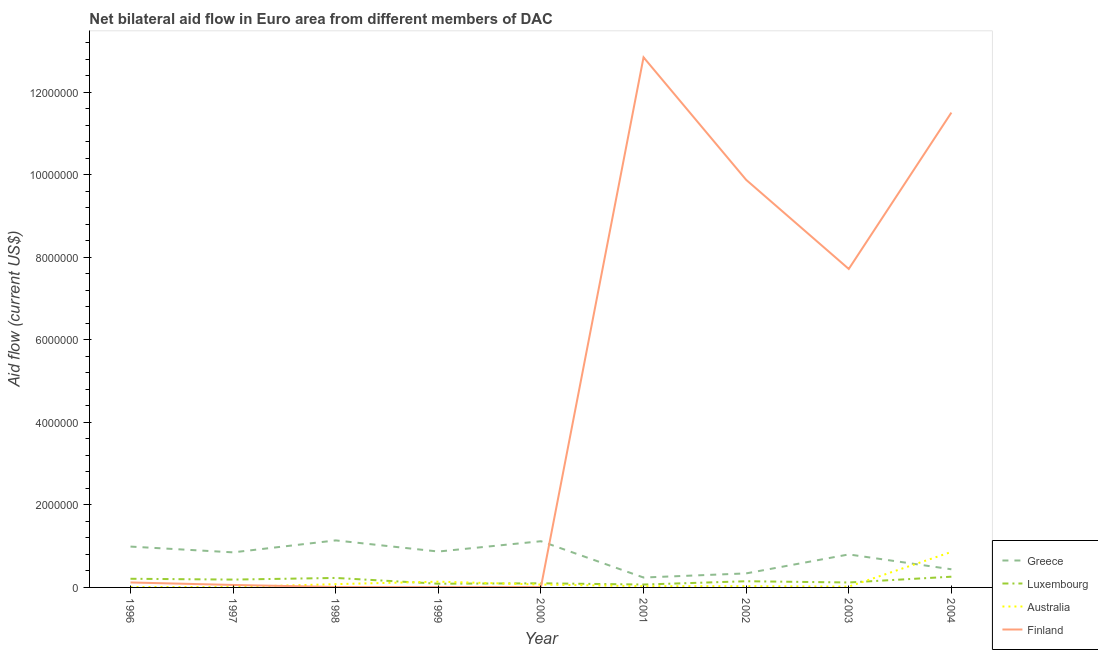Is the number of lines equal to the number of legend labels?
Your response must be concise. Yes. What is the amount of aid given by greece in 1997?
Give a very brief answer. 8.50e+05. Across all years, what is the maximum amount of aid given by finland?
Give a very brief answer. 1.28e+07. Across all years, what is the minimum amount of aid given by australia?
Your answer should be very brief. 10000. In which year was the amount of aid given by greece maximum?
Provide a succinct answer. 1998. In which year was the amount of aid given by australia minimum?
Provide a succinct answer. 1996. What is the total amount of aid given by luxembourg in the graph?
Offer a terse response. 1.42e+06. What is the difference between the amount of aid given by finland in 1996 and that in 1997?
Offer a terse response. 6.00e+04. What is the difference between the amount of aid given by australia in 1997 and the amount of aid given by finland in 2004?
Offer a very short reply. -1.15e+07. What is the average amount of aid given by finland per year?
Keep it short and to the point. 4.69e+06. In the year 1998, what is the difference between the amount of aid given by luxembourg and amount of aid given by australia?
Provide a succinct answer. 1.50e+05. In how many years, is the amount of aid given by australia greater than 1200000 US$?
Your answer should be very brief. 0. Is the amount of aid given by australia in 1997 less than that in 2000?
Offer a very short reply. Yes. Is the difference between the amount of aid given by luxembourg in 1999 and 2002 greater than the difference between the amount of aid given by finland in 1999 and 2002?
Ensure brevity in your answer.  Yes. What is the difference between the highest and the second highest amount of aid given by finland?
Ensure brevity in your answer.  1.34e+06. What is the difference between the highest and the lowest amount of aid given by australia?
Provide a short and direct response. 8.50e+05. In how many years, is the amount of aid given by australia greater than the average amount of aid given by australia taken over all years?
Offer a very short reply. 2. Is the sum of the amount of aid given by luxembourg in 2002 and 2003 greater than the maximum amount of aid given by finland across all years?
Offer a very short reply. No. Does the amount of aid given by greece monotonically increase over the years?
Provide a short and direct response. No. Is the amount of aid given by australia strictly greater than the amount of aid given by luxembourg over the years?
Provide a short and direct response. No. How many lines are there?
Offer a terse response. 4. What is the difference between two consecutive major ticks on the Y-axis?
Your response must be concise. 2.00e+06. How are the legend labels stacked?
Your response must be concise. Vertical. What is the title of the graph?
Ensure brevity in your answer.  Net bilateral aid flow in Euro area from different members of DAC. Does "Permission" appear as one of the legend labels in the graph?
Give a very brief answer. No. What is the label or title of the X-axis?
Keep it short and to the point. Year. What is the Aid flow (current US$) of Greece in 1996?
Your answer should be very brief. 9.90e+05. What is the Aid flow (current US$) in Luxembourg in 1996?
Make the answer very short. 2.10e+05. What is the Aid flow (current US$) in Australia in 1996?
Your response must be concise. 10000. What is the Aid flow (current US$) of Finland in 1996?
Provide a short and direct response. 1.20e+05. What is the Aid flow (current US$) in Greece in 1997?
Provide a succinct answer. 8.50e+05. What is the Aid flow (current US$) of Luxembourg in 1997?
Provide a succinct answer. 1.90e+05. What is the Aid flow (current US$) of Finland in 1997?
Make the answer very short. 6.00e+04. What is the Aid flow (current US$) in Greece in 1998?
Give a very brief answer. 1.14e+06. What is the Aid flow (current US$) of Greece in 1999?
Your answer should be very brief. 8.70e+05. What is the Aid flow (current US$) of Australia in 1999?
Provide a succinct answer. 1.40e+05. What is the Aid flow (current US$) of Finland in 1999?
Give a very brief answer. 10000. What is the Aid flow (current US$) in Greece in 2000?
Offer a very short reply. 1.12e+06. What is the Aid flow (current US$) of Luxembourg in 2000?
Offer a very short reply. 1.00e+05. What is the Aid flow (current US$) of Greece in 2001?
Offer a terse response. 2.40e+05. What is the Aid flow (current US$) in Finland in 2001?
Your answer should be compact. 1.28e+07. What is the Aid flow (current US$) of Australia in 2002?
Provide a short and direct response. 3.00e+04. What is the Aid flow (current US$) of Finland in 2002?
Offer a very short reply. 9.88e+06. What is the Aid flow (current US$) in Luxembourg in 2003?
Your answer should be very brief. 1.20e+05. What is the Aid flow (current US$) of Finland in 2003?
Your answer should be compact. 7.72e+06. What is the Aid flow (current US$) of Australia in 2004?
Offer a very short reply. 8.60e+05. What is the Aid flow (current US$) of Finland in 2004?
Your answer should be very brief. 1.15e+07. Across all years, what is the maximum Aid flow (current US$) of Greece?
Ensure brevity in your answer.  1.14e+06. Across all years, what is the maximum Aid flow (current US$) of Australia?
Your answer should be very brief. 8.60e+05. Across all years, what is the maximum Aid flow (current US$) in Finland?
Make the answer very short. 1.28e+07. Across all years, what is the minimum Aid flow (current US$) of Greece?
Give a very brief answer. 2.40e+05. Across all years, what is the minimum Aid flow (current US$) in Luxembourg?
Offer a terse response. 7.00e+04. Across all years, what is the minimum Aid flow (current US$) in Australia?
Your response must be concise. 10000. Across all years, what is the minimum Aid flow (current US$) of Finland?
Give a very brief answer. 10000. What is the total Aid flow (current US$) in Greece in the graph?
Ensure brevity in your answer.  6.79e+06. What is the total Aid flow (current US$) in Luxembourg in the graph?
Your answer should be compact. 1.42e+06. What is the total Aid flow (current US$) in Australia in the graph?
Provide a succinct answer. 1.25e+06. What is the total Aid flow (current US$) in Finland in the graph?
Your response must be concise. 4.22e+07. What is the difference between the Aid flow (current US$) of Greece in 1996 and that in 1997?
Make the answer very short. 1.40e+05. What is the difference between the Aid flow (current US$) of Australia in 1996 and that in 1997?
Your response must be concise. 0. What is the difference between the Aid flow (current US$) in Luxembourg in 1996 and that in 1998?
Make the answer very short. -2.00e+04. What is the difference between the Aid flow (current US$) of Australia in 1996 and that in 1998?
Provide a succinct answer. -7.00e+04. What is the difference between the Aid flow (current US$) of Luxembourg in 1996 and that in 1999?
Make the answer very short. 1.20e+05. What is the difference between the Aid flow (current US$) in Greece in 1996 and that in 2000?
Offer a very short reply. -1.30e+05. What is the difference between the Aid flow (current US$) in Luxembourg in 1996 and that in 2000?
Give a very brief answer. 1.10e+05. What is the difference between the Aid flow (current US$) of Greece in 1996 and that in 2001?
Give a very brief answer. 7.50e+05. What is the difference between the Aid flow (current US$) of Finland in 1996 and that in 2001?
Your answer should be very brief. -1.27e+07. What is the difference between the Aid flow (current US$) of Greece in 1996 and that in 2002?
Offer a terse response. 6.50e+05. What is the difference between the Aid flow (current US$) of Australia in 1996 and that in 2002?
Your answer should be very brief. -2.00e+04. What is the difference between the Aid flow (current US$) of Finland in 1996 and that in 2002?
Provide a short and direct response. -9.76e+06. What is the difference between the Aid flow (current US$) of Australia in 1996 and that in 2003?
Provide a succinct answer. -10000. What is the difference between the Aid flow (current US$) of Finland in 1996 and that in 2003?
Your answer should be very brief. -7.60e+06. What is the difference between the Aid flow (current US$) in Greece in 1996 and that in 2004?
Your response must be concise. 5.50e+05. What is the difference between the Aid flow (current US$) in Australia in 1996 and that in 2004?
Your answer should be compact. -8.50e+05. What is the difference between the Aid flow (current US$) in Finland in 1996 and that in 2004?
Give a very brief answer. -1.14e+07. What is the difference between the Aid flow (current US$) in Greece in 1997 and that in 1998?
Your answer should be compact. -2.90e+05. What is the difference between the Aid flow (current US$) of Greece in 1997 and that in 1999?
Make the answer very short. -2.00e+04. What is the difference between the Aid flow (current US$) of Luxembourg in 1997 and that in 1999?
Give a very brief answer. 1.00e+05. What is the difference between the Aid flow (current US$) in Australia in 1997 and that in 1999?
Offer a very short reply. -1.30e+05. What is the difference between the Aid flow (current US$) of Finland in 1997 and that in 1999?
Provide a succinct answer. 5.00e+04. What is the difference between the Aid flow (current US$) of Greece in 1997 and that in 2000?
Give a very brief answer. -2.70e+05. What is the difference between the Aid flow (current US$) in Luxembourg in 1997 and that in 2000?
Offer a very short reply. 9.00e+04. What is the difference between the Aid flow (current US$) in Australia in 1997 and that in 2000?
Your response must be concise. -6.00e+04. What is the difference between the Aid flow (current US$) in Greece in 1997 and that in 2001?
Ensure brevity in your answer.  6.10e+05. What is the difference between the Aid flow (current US$) in Luxembourg in 1997 and that in 2001?
Keep it short and to the point. 1.20e+05. What is the difference between the Aid flow (current US$) in Australia in 1997 and that in 2001?
Offer a very short reply. -2.00e+04. What is the difference between the Aid flow (current US$) of Finland in 1997 and that in 2001?
Your answer should be compact. -1.28e+07. What is the difference between the Aid flow (current US$) in Greece in 1997 and that in 2002?
Keep it short and to the point. 5.10e+05. What is the difference between the Aid flow (current US$) in Luxembourg in 1997 and that in 2002?
Your answer should be compact. 4.00e+04. What is the difference between the Aid flow (current US$) of Australia in 1997 and that in 2002?
Provide a short and direct response. -2.00e+04. What is the difference between the Aid flow (current US$) of Finland in 1997 and that in 2002?
Make the answer very short. -9.82e+06. What is the difference between the Aid flow (current US$) of Greece in 1997 and that in 2003?
Provide a succinct answer. 5.00e+04. What is the difference between the Aid flow (current US$) in Australia in 1997 and that in 2003?
Your answer should be compact. -10000. What is the difference between the Aid flow (current US$) in Finland in 1997 and that in 2003?
Keep it short and to the point. -7.66e+06. What is the difference between the Aid flow (current US$) in Luxembourg in 1997 and that in 2004?
Your answer should be very brief. -7.00e+04. What is the difference between the Aid flow (current US$) of Australia in 1997 and that in 2004?
Make the answer very short. -8.50e+05. What is the difference between the Aid flow (current US$) of Finland in 1997 and that in 2004?
Your response must be concise. -1.14e+07. What is the difference between the Aid flow (current US$) in Greece in 1998 and that in 1999?
Ensure brevity in your answer.  2.70e+05. What is the difference between the Aid flow (current US$) in Luxembourg in 1998 and that in 1999?
Keep it short and to the point. 1.40e+05. What is the difference between the Aid flow (current US$) of Australia in 1998 and that in 1999?
Offer a terse response. -6.00e+04. What is the difference between the Aid flow (current US$) of Luxembourg in 1998 and that in 2000?
Ensure brevity in your answer.  1.30e+05. What is the difference between the Aid flow (current US$) of Australia in 1998 and that in 2000?
Your answer should be compact. 10000. What is the difference between the Aid flow (current US$) in Finland in 1998 and that in 2001?
Make the answer very short. -1.28e+07. What is the difference between the Aid flow (current US$) in Greece in 1998 and that in 2002?
Keep it short and to the point. 8.00e+05. What is the difference between the Aid flow (current US$) in Luxembourg in 1998 and that in 2002?
Give a very brief answer. 8.00e+04. What is the difference between the Aid flow (current US$) in Australia in 1998 and that in 2002?
Provide a short and direct response. 5.00e+04. What is the difference between the Aid flow (current US$) of Finland in 1998 and that in 2002?
Your answer should be compact. -9.87e+06. What is the difference between the Aid flow (current US$) of Finland in 1998 and that in 2003?
Provide a short and direct response. -7.71e+06. What is the difference between the Aid flow (current US$) of Greece in 1998 and that in 2004?
Your answer should be compact. 7.00e+05. What is the difference between the Aid flow (current US$) of Australia in 1998 and that in 2004?
Make the answer very short. -7.80e+05. What is the difference between the Aid flow (current US$) of Finland in 1998 and that in 2004?
Your answer should be compact. -1.15e+07. What is the difference between the Aid flow (current US$) in Luxembourg in 1999 and that in 2000?
Give a very brief answer. -10000. What is the difference between the Aid flow (current US$) of Finland in 1999 and that in 2000?
Offer a very short reply. 0. What is the difference between the Aid flow (current US$) in Greece in 1999 and that in 2001?
Provide a short and direct response. 6.30e+05. What is the difference between the Aid flow (current US$) in Luxembourg in 1999 and that in 2001?
Provide a succinct answer. 2.00e+04. What is the difference between the Aid flow (current US$) of Australia in 1999 and that in 2001?
Your answer should be very brief. 1.10e+05. What is the difference between the Aid flow (current US$) in Finland in 1999 and that in 2001?
Your answer should be very brief. -1.28e+07. What is the difference between the Aid flow (current US$) in Greece in 1999 and that in 2002?
Make the answer very short. 5.30e+05. What is the difference between the Aid flow (current US$) in Luxembourg in 1999 and that in 2002?
Your answer should be very brief. -6.00e+04. What is the difference between the Aid flow (current US$) in Australia in 1999 and that in 2002?
Your response must be concise. 1.10e+05. What is the difference between the Aid flow (current US$) of Finland in 1999 and that in 2002?
Your answer should be very brief. -9.87e+06. What is the difference between the Aid flow (current US$) in Greece in 1999 and that in 2003?
Provide a succinct answer. 7.00e+04. What is the difference between the Aid flow (current US$) of Australia in 1999 and that in 2003?
Your response must be concise. 1.20e+05. What is the difference between the Aid flow (current US$) in Finland in 1999 and that in 2003?
Offer a terse response. -7.71e+06. What is the difference between the Aid flow (current US$) in Greece in 1999 and that in 2004?
Your answer should be very brief. 4.30e+05. What is the difference between the Aid flow (current US$) in Luxembourg in 1999 and that in 2004?
Offer a very short reply. -1.70e+05. What is the difference between the Aid flow (current US$) of Australia in 1999 and that in 2004?
Your answer should be compact. -7.20e+05. What is the difference between the Aid flow (current US$) in Finland in 1999 and that in 2004?
Provide a short and direct response. -1.15e+07. What is the difference between the Aid flow (current US$) in Greece in 2000 and that in 2001?
Ensure brevity in your answer.  8.80e+05. What is the difference between the Aid flow (current US$) of Finland in 2000 and that in 2001?
Give a very brief answer. -1.28e+07. What is the difference between the Aid flow (current US$) of Greece in 2000 and that in 2002?
Ensure brevity in your answer.  7.80e+05. What is the difference between the Aid flow (current US$) of Luxembourg in 2000 and that in 2002?
Offer a terse response. -5.00e+04. What is the difference between the Aid flow (current US$) in Australia in 2000 and that in 2002?
Offer a terse response. 4.00e+04. What is the difference between the Aid flow (current US$) of Finland in 2000 and that in 2002?
Make the answer very short. -9.87e+06. What is the difference between the Aid flow (current US$) of Greece in 2000 and that in 2003?
Offer a very short reply. 3.20e+05. What is the difference between the Aid flow (current US$) of Luxembourg in 2000 and that in 2003?
Your answer should be compact. -2.00e+04. What is the difference between the Aid flow (current US$) of Finland in 2000 and that in 2003?
Provide a short and direct response. -7.71e+06. What is the difference between the Aid flow (current US$) in Greece in 2000 and that in 2004?
Keep it short and to the point. 6.80e+05. What is the difference between the Aid flow (current US$) in Luxembourg in 2000 and that in 2004?
Your response must be concise. -1.60e+05. What is the difference between the Aid flow (current US$) in Australia in 2000 and that in 2004?
Your answer should be very brief. -7.90e+05. What is the difference between the Aid flow (current US$) in Finland in 2000 and that in 2004?
Provide a succinct answer. -1.15e+07. What is the difference between the Aid flow (current US$) of Finland in 2001 and that in 2002?
Provide a short and direct response. 2.97e+06. What is the difference between the Aid flow (current US$) in Greece in 2001 and that in 2003?
Make the answer very short. -5.60e+05. What is the difference between the Aid flow (current US$) of Luxembourg in 2001 and that in 2003?
Offer a terse response. -5.00e+04. What is the difference between the Aid flow (current US$) of Australia in 2001 and that in 2003?
Provide a short and direct response. 10000. What is the difference between the Aid flow (current US$) in Finland in 2001 and that in 2003?
Provide a succinct answer. 5.13e+06. What is the difference between the Aid flow (current US$) of Greece in 2001 and that in 2004?
Your response must be concise. -2.00e+05. What is the difference between the Aid flow (current US$) in Australia in 2001 and that in 2004?
Offer a very short reply. -8.30e+05. What is the difference between the Aid flow (current US$) in Finland in 2001 and that in 2004?
Make the answer very short. 1.34e+06. What is the difference between the Aid flow (current US$) of Greece in 2002 and that in 2003?
Your answer should be very brief. -4.60e+05. What is the difference between the Aid flow (current US$) of Luxembourg in 2002 and that in 2003?
Offer a terse response. 3.00e+04. What is the difference between the Aid flow (current US$) in Finland in 2002 and that in 2003?
Offer a terse response. 2.16e+06. What is the difference between the Aid flow (current US$) of Greece in 2002 and that in 2004?
Your answer should be compact. -1.00e+05. What is the difference between the Aid flow (current US$) in Luxembourg in 2002 and that in 2004?
Ensure brevity in your answer.  -1.10e+05. What is the difference between the Aid flow (current US$) in Australia in 2002 and that in 2004?
Ensure brevity in your answer.  -8.30e+05. What is the difference between the Aid flow (current US$) in Finland in 2002 and that in 2004?
Keep it short and to the point. -1.63e+06. What is the difference between the Aid flow (current US$) in Greece in 2003 and that in 2004?
Your answer should be very brief. 3.60e+05. What is the difference between the Aid flow (current US$) of Luxembourg in 2003 and that in 2004?
Ensure brevity in your answer.  -1.40e+05. What is the difference between the Aid flow (current US$) of Australia in 2003 and that in 2004?
Provide a succinct answer. -8.40e+05. What is the difference between the Aid flow (current US$) of Finland in 2003 and that in 2004?
Keep it short and to the point. -3.79e+06. What is the difference between the Aid flow (current US$) in Greece in 1996 and the Aid flow (current US$) in Luxembourg in 1997?
Provide a succinct answer. 8.00e+05. What is the difference between the Aid flow (current US$) in Greece in 1996 and the Aid flow (current US$) in Australia in 1997?
Your answer should be very brief. 9.80e+05. What is the difference between the Aid flow (current US$) of Greece in 1996 and the Aid flow (current US$) of Finland in 1997?
Provide a short and direct response. 9.30e+05. What is the difference between the Aid flow (current US$) of Luxembourg in 1996 and the Aid flow (current US$) of Finland in 1997?
Your response must be concise. 1.50e+05. What is the difference between the Aid flow (current US$) of Australia in 1996 and the Aid flow (current US$) of Finland in 1997?
Give a very brief answer. -5.00e+04. What is the difference between the Aid flow (current US$) of Greece in 1996 and the Aid flow (current US$) of Luxembourg in 1998?
Ensure brevity in your answer.  7.60e+05. What is the difference between the Aid flow (current US$) in Greece in 1996 and the Aid flow (current US$) in Australia in 1998?
Your response must be concise. 9.10e+05. What is the difference between the Aid flow (current US$) of Greece in 1996 and the Aid flow (current US$) of Finland in 1998?
Provide a short and direct response. 9.80e+05. What is the difference between the Aid flow (current US$) of Australia in 1996 and the Aid flow (current US$) of Finland in 1998?
Your answer should be very brief. 0. What is the difference between the Aid flow (current US$) in Greece in 1996 and the Aid flow (current US$) in Luxembourg in 1999?
Your answer should be very brief. 9.00e+05. What is the difference between the Aid flow (current US$) of Greece in 1996 and the Aid flow (current US$) of Australia in 1999?
Ensure brevity in your answer.  8.50e+05. What is the difference between the Aid flow (current US$) of Greece in 1996 and the Aid flow (current US$) of Finland in 1999?
Provide a succinct answer. 9.80e+05. What is the difference between the Aid flow (current US$) in Luxembourg in 1996 and the Aid flow (current US$) in Finland in 1999?
Offer a very short reply. 2.00e+05. What is the difference between the Aid flow (current US$) of Australia in 1996 and the Aid flow (current US$) of Finland in 1999?
Ensure brevity in your answer.  0. What is the difference between the Aid flow (current US$) of Greece in 1996 and the Aid flow (current US$) of Luxembourg in 2000?
Offer a terse response. 8.90e+05. What is the difference between the Aid flow (current US$) of Greece in 1996 and the Aid flow (current US$) of Australia in 2000?
Ensure brevity in your answer.  9.20e+05. What is the difference between the Aid flow (current US$) in Greece in 1996 and the Aid flow (current US$) in Finland in 2000?
Your response must be concise. 9.80e+05. What is the difference between the Aid flow (current US$) of Luxembourg in 1996 and the Aid flow (current US$) of Finland in 2000?
Your answer should be compact. 2.00e+05. What is the difference between the Aid flow (current US$) in Australia in 1996 and the Aid flow (current US$) in Finland in 2000?
Offer a terse response. 0. What is the difference between the Aid flow (current US$) of Greece in 1996 and the Aid flow (current US$) of Luxembourg in 2001?
Your response must be concise. 9.20e+05. What is the difference between the Aid flow (current US$) of Greece in 1996 and the Aid flow (current US$) of Australia in 2001?
Give a very brief answer. 9.60e+05. What is the difference between the Aid flow (current US$) in Greece in 1996 and the Aid flow (current US$) in Finland in 2001?
Keep it short and to the point. -1.19e+07. What is the difference between the Aid flow (current US$) in Luxembourg in 1996 and the Aid flow (current US$) in Finland in 2001?
Give a very brief answer. -1.26e+07. What is the difference between the Aid flow (current US$) in Australia in 1996 and the Aid flow (current US$) in Finland in 2001?
Your answer should be very brief. -1.28e+07. What is the difference between the Aid flow (current US$) of Greece in 1996 and the Aid flow (current US$) of Luxembourg in 2002?
Provide a succinct answer. 8.40e+05. What is the difference between the Aid flow (current US$) in Greece in 1996 and the Aid flow (current US$) in Australia in 2002?
Make the answer very short. 9.60e+05. What is the difference between the Aid flow (current US$) of Greece in 1996 and the Aid flow (current US$) of Finland in 2002?
Keep it short and to the point. -8.89e+06. What is the difference between the Aid flow (current US$) in Luxembourg in 1996 and the Aid flow (current US$) in Finland in 2002?
Provide a short and direct response. -9.67e+06. What is the difference between the Aid flow (current US$) of Australia in 1996 and the Aid flow (current US$) of Finland in 2002?
Your response must be concise. -9.87e+06. What is the difference between the Aid flow (current US$) of Greece in 1996 and the Aid flow (current US$) of Luxembourg in 2003?
Make the answer very short. 8.70e+05. What is the difference between the Aid flow (current US$) of Greece in 1996 and the Aid flow (current US$) of Australia in 2003?
Provide a short and direct response. 9.70e+05. What is the difference between the Aid flow (current US$) of Greece in 1996 and the Aid flow (current US$) of Finland in 2003?
Keep it short and to the point. -6.73e+06. What is the difference between the Aid flow (current US$) of Luxembourg in 1996 and the Aid flow (current US$) of Finland in 2003?
Provide a short and direct response. -7.51e+06. What is the difference between the Aid flow (current US$) in Australia in 1996 and the Aid flow (current US$) in Finland in 2003?
Make the answer very short. -7.71e+06. What is the difference between the Aid flow (current US$) of Greece in 1996 and the Aid flow (current US$) of Luxembourg in 2004?
Provide a succinct answer. 7.30e+05. What is the difference between the Aid flow (current US$) of Greece in 1996 and the Aid flow (current US$) of Australia in 2004?
Make the answer very short. 1.30e+05. What is the difference between the Aid flow (current US$) in Greece in 1996 and the Aid flow (current US$) in Finland in 2004?
Provide a short and direct response. -1.05e+07. What is the difference between the Aid flow (current US$) in Luxembourg in 1996 and the Aid flow (current US$) in Australia in 2004?
Your answer should be very brief. -6.50e+05. What is the difference between the Aid flow (current US$) of Luxembourg in 1996 and the Aid flow (current US$) of Finland in 2004?
Make the answer very short. -1.13e+07. What is the difference between the Aid flow (current US$) of Australia in 1996 and the Aid flow (current US$) of Finland in 2004?
Provide a short and direct response. -1.15e+07. What is the difference between the Aid flow (current US$) in Greece in 1997 and the Aid flow (current US$) in Luxembourg in 1998?
Keep it short and to the point. 6.20e+05. What is the difference between the Aid flow (current US$) of Greece in 1997 and the Aid flow (current US$) of Australia in 1998?
Your answer should be very brief. 7.70e+05. What is the difference between the Aid flow (current US$) in Greece in 1997 and the Aid flow (current US$) in Finland in 1998?
Your answer should be compact. 8.40e+05. What is the difference between the Aid flow (current US$) of Luxembourg in 1997 and the Aid flow (current US$) of Finland in 1998?
Provide a succinct answer. 1.80e+05. What is the difference between the Aid flow (current US$) of Greece in 1997 and the Aid flow (current US$) of Luxembourg in 1999?
Your answer should be very brief. 7.60e+05. What is the difference between the Aid flow (current US$) in Greece in 1997 and the Aid flow (current US$) in Australia in 1999?
Your response must be concise. 7.10e+05. What is the difference between the Aid flow (current US$) of Greece in 1997 and the Aid flow (current US$) of Finland in 1999?
Your response must be concise. 8.40e+05. What is the difference between the Aid flow (current US$) in Australia in 1997 and the Aid flow (current US$) in Finland in 1999?
Offer a terse response. 0. What is the difference between the Aid flow (current US$) of Greece in 1997 and the Aid flow (current US$) of Luxembourg in 2000?
Provide a succinct answer. 7.50e+05. What is the difference between the Aid flow (current US$) in Greece in 1997 and the Aid flow (current US$) in Australia in 2000?
Give a very brief answer. 7.80e+05. What is the difference between the Aid flow (current US$) of Greece in 1997 and the Aid flow (current US$) of Finland in 2000?
Offer a very short reply. 8.40e+05. What is the difference between the Aid flow (current US$) of Greece in 1997 and the Aid flow (current US$) of Luxembourg in 2001?
Your answer should be compact. 7.80e+05. What is the difference between the Aid flow (current US$) in Greece in 1997 and the Aid flow (current US$) in Australia in 2001?
Provide a succinct answer. 8.20e+05. What is the difference between the Aid flow (current US$) in Greece in 1997 and the Aid flow (current US$) in Finland in 2001?
Make the answer very short. -1.20e+07. What is the difference between the Aid flow (current US$) in Luxembourg in 1997 and the Aid flow (current US$) in Australia in 2001?
Offer a very short reply. 1.60e+05. What is the difference between the Aid flow (current US$) in Luxembourg in 1997 and the Aid flow (current US$) in Finland in 2001?
Provide a succinct answer. -1.27e+07. What is the difference between the Aid flow (current US$) of Australia in 1997 and the Aid flow (current US$) of Finland in 2001?
Provide a short and direct response. -1.28e+07. What is the difference between the Aid flow (current US$) in Greece in 1997 and the Aid flow (current US$) in Luxembourg in 2002?
Provide a succinct answer. 7.00e+05. What is the difference between the Aid flow (current US$) in Greece in 1997 and the Aid flow (current US$) in Australia in 2002?
Give a very brief answer. 8.20e+05. What is the difference between the Aid flow (current US$) in Greece in 1997 and the Aid flow (current US$) in Finland in 2002?
Your answer should be very brief. -9.03e+06. What is the difference between the Aid flow (current US$) in Luxembourg in 1997 and the Aid flow (current US$) in Finland in 2002?
Make the answer very short. -9.69e+06. What is the difference between the Aid flow (current US$) in Australia in 1997 and the Aid flow (current US$) in Finland in 2002?
Offer a terse response. -9.87e+06. What is the difference between the Aid flow (current US$) in Greece in 1997 and the Aid flow (current US$) in Luxembourg in 2003?
Your response must be concise. 7.30e+05. What is the difference between the Aid flow (current US$) in Greece in 1997 and the Aid flow (current US$) in Australia in 2003?
Ensure brevity in your answer.  8.30e+05. What is the difference between the Aid flow (current US$) in Greece in 1997 and the Aid flow (current US$) in Finland in 2003?
Keep it short and to the point. -6.87e+06. What is the difference between the Aid flow (current US$) in Luxembourg in 1997 and the Aid flow (current US$) in Finland in 2003?
Give a very brief answer. -7.53e+06. What is the difference between the Aid flow (current US$) of Australia in 1997 and the Aid flow (current US$) of Finland in 2003?
Your response must be concise. -7.71e+06. What is the difference between the Aid flow (current US$) in Greece in 1997 and the Aid flow (current US$) in Luxembourg in 2004?
Ensure brevity in your answer.  5.90e+05. What is the difference between the Aid flow (current US$) of Greece in 1997 and the Aid flow (current US$) of Finland in 2004?
Offer a terse response. -1.07e+07. What is the difference between the Aid flow (current US$) in Luxembourg in 1997 and the Aid flow (current US$) in Australia in 2004?
Your answer should be very brief. -6.70e+05. What is the difference between the Aid flow (current US$) of Luxembourg in 1997 and the Aid flow (current US$) of Finland in 2004?
Your answer should be very brief. -1.13e+07. What is the difference between the Aid flow (current US$) of Australia in 1997 and the Aid flow (current US$) of Finland in 2004?
Offer a terse response. -1.15e+07. What is the difference between the Aid flow (current US$) in Greece in 1998 and the Aid flow (current US$) in Luxembourg in 1999?
Offer a very short reply. 1.05e+06. What is the difference between the Aid flow (current US$) of Greece in 1998 and the Aid flow (current US$) of Australia in 1999?
Offer a terse response. 1.00e+06. What is the difference between the Aid flow (current US$) of Greece in 1998 and the Aid flow (current US$) of Finland in 1999?
Ensure brevity in your answer.  1.13e+06. What is the difference between the Aid flow (current US$) in Luxembourg in 1998 and the Aid flow (current US$) in Finland in 1999?
Provide a short and direct response. 2.20e+05. What is the difference between the Aid flow (current US$) in Greece in 1998 and the Aid flow (current US$) in Luxembourg in 2000?
Offer a very short reply. 1.04e+06. What is the difference between the Aid flow (current US$) of Greece in 1998 and the Aid flow (current US$) of Australia in 2000?
Provide a succinct answer. 1.07e+06. What is the difference between the Aid flow (current US$) in Greece in 1998 and the Aid flow (current US$) in Finland in 2000?
Provide a short and direct response. 1.13e+06. What is the difference between the Aid flow (current US$) in Luxembourg in 1998 and the Aid flow (current US$) in Australia in 2000?
Your answer should be very brief. 1.60e+05. What is the difference between the Aid flow (current US$) of Luxembourg in 1998 and the Aid flow (current US$) of Finland in 2000?
Provide a short and direct response. 2.20e+05. What is the difference between the Aid flow (current US$) of Australia in 1998 and the Aid flow (current US$) of Finland in 2000?
Your answer should be compact. 7.00e+04. What is the difference between the Aid flow (current US$) in Greece in 1998 and the Aid flow (current US$) in Luxembourg in 2001?
Keep it short and to the point. 1.07e+06. What is the difference between the Aid flow (current US$) of Greece in 1998 and the Aid flow (current US$) of Australia in 2001?
Ensure brevity in your answer.  1.11e+06. What is the difference between the Aid flow (current US$) of Greece in 1998 and the Aid flow (current US$) of Finland in 2001?
Give a very brief answer. -1.17e+07. What is the difference between the Aid flow (current US$) of Luxembourg in 1998 and the Aid flow (current US$) of Australia in 2001?
Your answer should be compact. 2.00e+05. What is the difference between the Aid flow (current US$) in Luxembourg in 1998 and the Aid flow (current US$) in Finland in 2001?
Your answer should be compact. -1.26e+07. What is the difference between the Aid flow (current US$) of Australia in 1998 and the Aid flow (current US$) of Finland in 2001?
Provide a short and direct response. -1.28e+07. What is the difference between the Aid flow (current US$) of Greece in 1998 and the Aid flow (current US$) of Luxembourg in 2002?
Keep it short and to the point. 9.90e+05. What is the difference between the Aid flow (current US$) of Greece in 1998 and the Aid flow (current US$) of Australia in 2002?
Provide a succinct answer. 1.11e+06. What is the difference between the Aid flow (current US$) in Greece in 1998 and the Aid flow (current US$) in Finland in 2002?
Your response must be concise. -8.74e+06. What is the difference between the Aid flow (current US$) in Luxembourg in 1998 and the Aid flow (current US$) in Australia in 2002?
Give a very brief answer. 2.00e+05. What is the difference between the Aid flow (current US$) in Luxembourg in 1998 and the Aid flow (current US$) in Finland in 2002?
Keep it short and to the point. -9.65e+06. What is the difference between the Aid flow (current US$) in Australia in 1998 and the Aid flow (current US$) in Finland in 2002?
Your response must be concise. -9.80e+06. What is the difference between the Aid flow (current US$) in Greece in 1998 and the Aid flow (current US$) in Luxembourg in 2003?
Offer a very short reply. 1.02e+06. What is the difference between the Aid flow (current US$) of Greece in 1998 and the Aid flow (current US$) of Australia in 2003?
Your answer should be very brief. 1.12e+06. What is the difference between the Aid flow (current US$) in Greece in 1998 and the Aid flow (current US$) in Finland in 2003?
Provide a succinct answer. -6.58e+06. What is the difference between the Aid flow (current US$) in Luxembourg in 1998 and the Aid flow (current US$) in Australia in 2003?
Your answer should be very brief. 2.10e+05. What is the difference between the Aid flow (current US$) of Luxembourg in 1998 and the Aid flow (current US$) of Finland in 2003?
Ensure brevity in your answer.  -7.49e+06. What is the difference between the Aid flow (current US$) in Australia in 1998 and the Aid flow (current US$) in Finland in 2003?
Give a very brief answer. -7.64e+06. What is the difference between the Aid flow (current US$) in Greece in 1998 and the Aid flow (current US$) in Luxembourg in 2004?
Make the answer very short. 8.80e+05. What is the difference between the Aid flow (current US$) of Greece in 1998 and the Aid flow (current US$) of Finland in 2004?
Give a very brief answer. -1.04e+07. What is the difference between the Aid flow (current US$) of Luxembourg in 1998 and the Aid flow (current US$) of Australia in 2004?
Provide a short and direct response. -6.30e+05. What is the difference between the Aid flow (current US$) of Luxembourg in 1998 and the Aid flow (current US$) of Finland in 2004?
Keep it short and to the point. -1.13e+07. What is the difference between the Aid flow (current US$) of Australia in 1998 and the Aid flow (current US$) of Finland in 2004?
Provide a succinct answer. -1.14e+07. What is the difference between the Aid flow (current US$) of Greece in 1999 and the Aid flow (current US$) of Luxembourg in 2000?
Ensure brevity in your answer.  7.70e+05. What is the difference between the Aid flow (current US$) of Greece in 1999 and the Aid flow (current US$) of Finland in 2000?
Provide a succinct answer. 8.60e+05. What is the difference between the Aid flow (current US$) in Luxembourg in 1999 and the Aid flow (current US$) in Finland in 2000?
Keep it short and to the point. 8.00e+04. What is the difference between the Aid flow (current US$) in Greece in 1999 and the Aid flow (current US$) in Luxembourg in 2001?
Your answer should be compact. 8.00e+05. What is the difference between the Aid flow (current US$) of Greece in 1999 and the Aid flow (current US$) of Australia in 2001?
Give a very brief answer. 8.40e+05. What is the difference between the Aid flow (current US$) of Greece in 1999 and the Aid flow (current US$) of Finland in 2001?
Make the answer very short. -1.20e+07. What is the difference between the Aid flow (current US$) in Luxembourg in 1999 and the Aid flow (current US$) in Finland in 2001?
Your response must be concise. -1.28e+07. What is the difference between the Aid flow (current US$) in Australia in 1999 and the Aid flow (current US$) in Finland in 2001?
Give a very brief answer. -1.27e+07. What is the difference between the Aid flow (current US$) of Greece in 1999 and the Aid flow (current US$) of Luxembourg in 2002?
Provide a succinct answer. 7.20e+05. What is the difference between the Aid flow (current US$) of Greece in 1999 and the Aid flow (current US$) of Australia in 2002?
Make the answer very short. 8.40e+05. What is the difference between the Aid flow (current US$) in Greece in 1999 and the Aid flow (current US$) in Finland in 2002?
Give a very brief answer. -9.01e+06. What is the difference between the Aid flow (current US$) in Luxembourg in 1999 and the Aid flow (current US$) in Australia in 2002?
Offer a terse response. 6.00e+04. What is the difference between the Aid flow (current US$) in Luxembourg in 1999 and the Aid flow (current US$) in Finland in 2002?
Your answer should be compact. -9.79e+06. What is the difference between the Aid flow (current US$) of Australia in 1999 and the Aid flow (current US$) of Finland in 2002?
Offer a terse response. -9.74e+06. What is the difference between the Aid flow (current US$) of Greece in 1999 and the Aid flow (current US$) of Luxembourg in 2003?
Offer a terse response. 7.50e+05. What is the difference between the Aid flow (current US$) in Greece in 1999 and the Aid flow (current US$) in Australia in 2003?
Give a very brief answer. 8.50e+05. What is the difference between the Aid flow (current US$) of Greece in 1999 and the Aid flow (current US$) of Finland in 2003?
Your response must be concise. -6.85e+06. What is the difference between the Aid flow (current US$) of Luxembourg in 1999 and the Aid flow (current US$) of Australia in 2003?
Offer a very short reply. 7.00e+04. What is the difference between the Aid flow (current US$) of Luxembourg in 1999 and the Aid flow (current US$) of Finland in 2003?
Give a very brief answer. -7.63e+06. What is the difference between the Aid flow (current US$) in Australia in 1999 and the Aid flow (current US$) in Finland in 2003?
Keep it short and to the point. -7.58e+06. What is the difference between the Aid flow (current US$) in Greece in 1999 and the Aid flow (current US$) in Luxembourg in 2004?
Offer a very short reply. 6.10e+05. What is the difference between the Aid flow (current US$) in Greece in 1999 and the Aid flow (current US$) in Australia in 2004?
Your response must be concise. 10000. What is the difference between the Aid flow (current US$) in Greece in 1999 and the Aid flow (current US$) in Finland in 2004?
Your response must be concise. -1.06e+07. What is the difference between the Aid flow (current US$) in Luxembourg in 1999 and the Aid flow (current US$) in Australia in 2004?
Your answer should be compact. -7.70e+05. What is the difference between the Aid flow (current US$) of Luxembourg in 1999 and the Aid flow (current US$) of Finland in 2004?
Your answer should be very brief. -1.14e+07. What is the difference between the Aid flow (current US$) of Australia in 1999 and the Aid flow (current US$) of Finland in 2004?
Provide a short and direct response. -1.14e+07. What is the difference between the Aid flow (current US$) of Greece in 2000 and the Aid flow (current US$) of Luxembourg in 2001?
Offer a very short reply. 1.05e+06. What is the difference between the Aid flow (current US$) in Greece in 2000 and the Aid flow (current US$) in Australia in 2001?
Offer a terse response. 1.09e+06. What is the difference between the Aid flow (current US$) of Greece in 2000 and the Aid flow (current US$) of Finland in 2001?
Ensure brevity in your answer.  -1.17e+07. What is the difference between the Aid flow (current US$) in Luxembourg in 2000 and the Aid flow (current US$) in Australia in 2001?
Your answer should be compact. 7.00e+04. What is the difference between the Aid flow (current US$) of Luxembourg in 2000 and the Aid flow (current US$) of Finland in 2001?
Offer a very short reply. -1.28e+07. What is the difference between the Aid flow (current US$) in Australia in 2000 and the Aid flow (current US$) in Finland in 2001?
Provide a succinct answer. -1.28e+07. What is the difference between the Aid flow (current US$) of Greece in 2000 and the Aid flow (current US$) of Luxembourg in 2002?
Give a very brief answer. 9.70e+05. What is the difference between the Aid flow (current US$) in Greece in 2000 and the Aid flow (current US$) in Australia in 2002?
Your response must be concise. 1.09e+06. What is the difference between the Aid flow (current US$) of Greece in 2000 and the Aid flow (current US$) of Finland in 2002?
Your answer should be very brief. -8.76e+06. What is the difference between the Aid flow (current US$) in Luxembourg in 2000 and the Aid flow (current US$) in Australia in 2002?
Offer a very short reply. 7.00e+04. What is the difference between the Aid flow (current US$) in Luxembourg in 2000 and the Aid flow (current US$) in Finland in 2002?
Provide a short and direct response. -9.78e+06. What is the difference between the Aid flow (current US$) in Australia in 2000 and the Aid flow (current US$) in Finland in 2002?
Your response must be concise. -9.81e+06. What is the difference between the Aid flow (current US$) in Greece in 2000 and the Aid flow (current US$) in Australia in 2003?
Ensure brevity in your answer.  1.10e+06. What is the difference between the Aid flow (current US$) of Greece in 2000 and the Aid flow (current US$) of Finland in 2003?
Make the answer very short. -6.60e+06. What is the difference between the Aid flow (current US$) in Luxembourg in 2000 and the Aid flow (current US$) in Finland in 2003?
Offer a terse response. -7.62e+06. What is the difference between the Aid flow (current US$) in Australia in 2000 and the Aid flow (current US$) in Finland in 2003?
Make the answer very short. -7.65e+06. What is the difference between the Aid flow (current US$) in Greece in 2000 and the Aid flow (current US$) in Luxembourg in 2004?
Make the answer very short. 8.60e+05. What is the difference between the Aid flow (current US$) in Greece in 2000 and the Aid flow (current US$) in Australia in 2004?
Make the answer very short. 2.60e+05. What is the difference between the Aid flow (current US$) in Greece in 2000 and the Aid flow (current US$) in Finland in 2004?
Your answer should be very brief. -1.04e+07. What is the difference between the Aid flow (current US$) in Luxembourg in 2000 and the Aid flow (current US$) in Australia in 2004?
Offer a terse response. -7.60e+05. What is the difference between the Aid flow (current US$) in Luxembourg in 2000 and the Aid flow (current US$) in Finland in 2004?
Ensure brevity in your answer.  -1.14e+07. What is the difference between the Aid flow (current US$) in Australia in 2000 and the Aid flow (current US$) in Finland in 2004?
Offer a very short reply. -1.14e+07. What is the difference between the Aid flow (current US$) of Greece in 2001 and the Aid flow (current US$) of Luxembourg in 2002?
Provide a short and direct response. 9.00e+04. What is the difference between the Aid flow (current US$) in Greece in 2001 and the Aid flow (current US$) in Australia in 2002?
Your response must be concise. 2.10e+05. What is the difference between the Aid flow (current US$) of Greece in 2001 and the Aid flow (current US$) of Finland in 2002?
Give a very brief answer. -9.64e+06. What is the difference between the Aid flow (current US$) in Luxembourg in 2001 and the Aid flow (current US$) in Australia in 2002?
Your response must be concise. 4.00e+04. What is the difference between the Aid flow (current US$) in Luxembourg in 2001 and the Aid flow (current US$) in Finland in 2002?
Offer a terse response. -9.81e+06. What is the difference between the Aid flow (current US$) of Australia in 2001 and the Aid flow (current US$) of Finland in 2002?
Ensure brevity in your answer.  -9.85e+06. What is the difference between the Aid flow (current US$) in Greece in 2001 and the Aid flow (current US$) in Finland in 2003?
Keep it short and to the point. -7.48e+06. What is the difference between the Aid flow (current US$) in Luxembourg in 2001 and the Aid flow (current US$) in Finland in 2003?
Offer a very short reply. -7.65e+06. What is the difference between the Aid flow (current US$) of Australia in 2001 and the Aid flow (current US$) of Finland in 2003?
Offer a terse response. -7.69e+06. What is the difference between the Aid flow (current US$) in Greece in 2001 and the Aid flow (current US$) in Australia in 2004?
Provide a short and direct response. -6.20e+05. What is the difference between the Aid flow (current US$) in Greece in 2001 and the Aid flow (current US$) in Finland in 2004?
Ensure brevity in your answer.  -1.13e+07. What is the difference between the Aid flow (current US$) in Luxembourg in 2001 and the Aid flow (current US$) in Australia in 2004?
Your answer should be compact. -7.90e+05. What is the difference between the Aid flow (current US$) in Luxembourg in 2001 and the Aid flow (current US$) in Finland in 2004?
Keep it short and to the point. -1.14e+07. What is the difference between the Aid flow (current US$) in Australia in 2001 and the Aid flow (current US$) in Finland in 2004?
Ensure brevity in your answer.  -1.15e+07. What is the difference between the Aid flow (current US$) in Greece in 2002 and the Aid flow (current US$) in Finland in 2003?
Provide a succinct answer. -7.38e+06. What is the difference between the Aid flow (current US$) of Luxembourg in 2002 and the Aid flow (current US$) of Australia in 2003?
Ensure brevity in your answer.  1.30e+05. What is the difference between the Aid flow (current US$) in Luxembourg in 2002 and the Aid flow (current US$) in Finland in 2003?
Provide a short and direct response. -7.57e+06. What is the difference between the Aid flow (current US$) in Australia in 2002 and the Aid flow (current US$) in Finland in 2003?
Ensure brevity in your answer.  -7.69e+06. What is the difference between the Aid flow (current US$) of Greece in 2002 and the Aid flow (current US$) of Australia in 2004?
Offer a terse response. -5.20e+05. What is the difference between the Aid flow (current US$) of Greece in 2002 and the Aid flow (current US$) of Finland in 2004?
Ensure brevity in your answer.  -1.12e+07. What is the difference between the Aid flow (current US$) in Luxembourg in 2002 and the Aid flow (current US$) in Australia in 2004?
Give a very brief answer. -7.10e+05. What is the difference between the Aid flow (current US$) of Luxembourg in 2002 and the Aid flow (current US$) of Finland in 2004?
Make the answer very short. -1.14e+07. What is the difference between the Aid flow (current US$) of Australia in 2002 and the Aid flow (current US$) of Finland in 2004?
Provide a succinct answer. -1.15e+07. What is the difference between the Aid flow (current US$) of Greece in 2003 and the Aid flow (current US$) of Luxembourg in 2004?
Offer a very short reply. 5.40e+05. What is the difference between the Aid flow (current US$) in Greece in 2003 and the Aid flow (current US$) in Australia in 2004?
Make the answer very short. -6.00e+04. What is the difference between the Aid flow (current US$) in Greece in 2003 and the Aid flow (current US$) in Finland in 2004?
Provide a succinct answer. -1.07e+07. What is the difference between the Aid flow (current US$) in Luxembourg in 2003 and the Aid flow (current US$) in Australia in 2004?
Provide a succinct answer. -7.40e+05. What is the difference between the Aid flow (current US$) of Luxembourg in 2003 and the Aid flow (current US$) of Finland in 2004?
Ensure brevity in your answer.  -1.14e+07. What is the difference between the Aid flow (current US$) of Australia in 2003 and the Aid flow (current US$) of Finland in 2004?
Offer a very short reply. -1.15e+07. What is the average Aid flow (current US$) in Greece per year?
Make the answer very short. 7.54e+05. What is the average Aid flow (current US$) of Luxembourg per year?
Your answer should be very brief. 1.58e+05. What is the average Aid flow (current US$) of Australia per year?
Keep it short and to the point. 1.39e+05. What is the average Aid flow (current US$) of Finland per year?
Keep it short and to the point. 4.69e+06. In the year 1996, what is the difference between the Aid flow (current US$) of Greece and Aid flow (current US$) of Luxembourg?
Ensure brevity in your answer.  7.80e+05. In the year 1996, what is the difference between the Aid flow (current US$) in Greece and Aid flow (current US$) in Australia?
Offer a very short reply. 9.80e+05. In the year 1996, what is the difference between the Aid flow (current US$) in Greece and Aid flow (current US$) in Finland?
Ensure brevity in your answer.  8.70e+05. In the year 1996, what is the difference between the Aid flow (current US$) in Luxembourg and Aid flow (current US$) in Australia?
Ensure brevity in your answer.  2.00e+05. In the year 1996, what is the difference between the Aid flow (current US$) of Luxembourg and Aid flow (current US$) of Finland?
Your response must be concise. 9.00e+04. In the year 1997, what is the difference between the Aid flow (current US$) of Greece and Aid flow (current US$) of Luxembourg?
Provide a short and direct response. 6.60e+05. In the year 1997, what is the difference between the Aid flow (current US$) in Greece and Aid flow (current US$) in Australia?
Ensure brevity in your answer.  8.40e+05. In the year 1997, what is the difference between the Aid flow (current US$) in Greece and Aid flow (current US$) in Finland?
Provide a short and direct response. 7.90e+05. In the year 1997, what is the difference between the Aid flow (current US$) of Luxembourg and Aid flow (current US$) of Australia?
Ensure brevity in your answer.  1.80e+05. In the year 1998, what is the difference between the Aid flow (current US$) of Greece and Aid flow (current US$) of Luxembourg?
Your answer should be very brief. 9.10e+05. In the year 1998, what is the difference between the Aid flow (current US$) in Greece and Aid flow (current US$) in Australia?
Provide a succinct answer. 1.06e+06. In the year 1998, what is the difference between the Aid flow (current US$) in Greece and Aid flow (current US$) in Finland?
Provide a short and direct response. 1.13e+06. In the year 1998, what is the difference between the Aid flow (current US$) in Luxembourg and Aid flow (current US$) in Australia?
Your answer should be very brief. 1.50e+05. In the year 1998, what is the difference between the Aid flow (current US$) in Luxembourg and Aid flow (current US$) in Finland?
Provide a short and direct response. 2.20e+05. In the year 1998, what is the difference between the Aid flow (current US$) of Australia and Aid flow (current US$) of Finland?
Your answer should be compact. 7.00e+04. In the year 1999, what is the difference between the Aid flow (current US$) in Greece and Aid flow (current US$) in Luxembourg?
Your response must be concise. 7.80e+05. In the year 1999, what is the difference between the Aid flow (current US$) of Greece and Aid flow (current US$) of Australia?
Your response must be concise. 7.30e+05. In the year 1999, what is the difference between the Aid flow (current US$) of Greece and Aid flow (current US$) of Finland?
Your answer should be very brief. 8.60e+05. In the year 2000, what is the difference between the Aid flow (current US$) of Greece and Aid flow (current US$) of Luxembourg?
Keep it short and to the point. 1.02e+06. In the year 2000, what is the difference between the Aid flow (current US$) in Greece and Aid flow (current US$) in Australia?
Provide a short and direct response. 1.05e+06. In the year 2000, what is the difference between the Aid flow (current US$) in Greece and Aid flow (current US$) in Finland?
Keep it short and to the point. 1.11e+06. In the year 2000, what is the difference between the Aid flow (current US$) of Luxembourg and Aid flow (current US$) of Australia?
Provide a short and direct response. 3.00e+04. In the year 2000, what is the difference between the Aid flow (current US$) in Luxembourg and Aid flow (current US$) in Finland?
Your response must be concise. 9.00e+04. In the year 2000, what is the difference between the Aid flow (current US$) of Australia and Aid flow (current US$) of Finland?
Provide a short and direct response. 6.00e+04. In the year 2001, what is the difference between the Aid flow (current US$) in Greece and Aid flow (current US$) in Luxembourg?
Keep it short and to the point. 1.70e+05. In the year 2001, what is the difference between the Aid flow (current US$) in Greece and Aid flow (current US$) in Australia?
Offer a terse response. 2.10e+05. In the year 2001, what is the difference between the Aid flow (current US$) of Greece and Aid flow (current US$) of Finland?
Make the answer very short. -1.26e+07. In the year 2001, what is the difference between the Aid flow (current US$) of Luxembourg and Aid flow (current US$) of Australia?
Offer a terse response. 4.00e+04. In the year 2001, what is the difference between the Aid flow (current US$) of Luxembourg and Aid flow (current US$) of Finland?
Provide a short and direct response. -1.28e+07. In the year 2001, what is the difference between the Aid flow (current US$) of Australia and Aid flow (current US$) of Finland?
Ensure brevity in your answer.  -1.28e+07. In the year 2002, what is the difference between the Aid flow (current US$) of Greece and Aid flow (current US$) of Australia?
Your answer should be compact. 3.10e+05. In the year 2002, what is the difference between the Aid flow (current US$) in Greece and Aid flow (current US$) in Finland?
Provide a short and direct response. -9.54e+06. In the year 2002, what is the difference between the Aid flow (current US$) of Luxembourg and Aid flow (current US$) of Australia?
Ensure brevity in your answer.  1.20e+05. In the year 2002, what is the difference between the Aid flow (current US$) of Luxembourg and Aid flow (current US$) of Finland?
Make the answer very short. -9.73e+06. In the year 2002, what is the difference between the Aid flow (current US$) in Australia and Aid flow (current US$) in Finland?
Your answer should be very brief. -9.85e+06. In the year 2003, what is the difference between the Aid flow (current US$) in Greece and Aid flow (current US$) in Luxembourg?
Provide a succinct answer. 6.80e+05. In the year 2003, what is the difference between the Aid flow (current US$) of Greece and Aid flow (current US$) of Australia?
Provide a short and direct response. 7.80e+05. In the year 2003, what is the difference between the Aid flow (current US$) of Greece and Aid flow (current US$) of Finland?
Give a very brief answer. -6.92e+06. In the year 2003, what is the difference between the Aid flow (current US$) of Luxembourg and Aid flow (current US$) of Finland?
Provide a succinct answer. -7.60e+06. In the year 2003, what is the difference between the Aid flow (current US$) in Australia and Aid flow (current US$) in Finland?
Your answer should be compact. -7.70e+06. In the year 2004, what is the difference between the Aid flow (current US$) of Greece and Aid flow (current US$) of Luxembourg?
Offer a very short reply. 1.80e+05. In the year 2004, what is the difference between the Aid flow (current US$) of Greece and Aid flow (current US$) of Australia?
Provide a short and direct response. -4.20e+05. In the year 2004, what is the difference between the Aid flow (current US$) in Greece and Aid flow (current US$) in Finland?
Ensure brevity in your answer.  -1.11e+07. In the year 2004, what is the difference between the Aid flow (current US$) in Luxembourg and Aid flow (current US$) in Australia?
Your answer should be very brief. -6.00e+05. In the year 2004, what is the difference between the Aid flow (current US$) of Luxembourg and Aid flow (current US$) of Finland?
Keep it short and to the point. -1.12e+07. In the year 2004, what is the difference between the Aid flow (current US$) in Australia and Aid flow (current US$) in Finland?
Offer a terse response. -1.06e+07. What is the ratio of the Aid flow (current US$) in Greece in 1996 to that in 1997?
Your answer should be very brief. 1.16. What is the ratio of the Aid flow (current US$) of Luxembourg in 1996 to that in 1997?
Offer a terse response. 1.11. What is the ratio of the Aid flow (current US$) of Australia in 1996 to that in 1997?
Offer a very short reply. 1. What is the ratio of the Aid flow (current US$) of Greece in 1996 to that in 1998?
Provide a succinct answer. 0.87. What is the ratio of the Aid flow (current US$) of Luxembourg in 1996 to that in 1998?
Offer a terse response. 0.91. What is the ratio of the Aid flow (current US$) of Greece in 1996 to that in 1999?
Offer a terse response. 1.14. What is the ratio of the Aid flow (current US$) in Luxembourg in 1996 to that in 1999?
Provide a succinct answer. 2.33. What is the ratio of the Aid flow (current US$) of Australia in 1996 to that in 1999?
Offer a terse response. 0.07. What is the ratio of the Aid flow (current US$) in Finland in 1996 to that in 1999?
Your answer should be compact. 12. What is the ratio of the Aid flow (current US$) of Greece in 1996 to that in 2000?
Ensure brevity in your answer.  0.88. What is the ratio of the Aid flow (current US$) of Australia in 1996 to that in 2000?
Ensure brevity in your answer.  0.14. What is the ratio of the Aid flow (current US$) of Finland in 1996 to that in 2000?
Ensure brevity in your answer.  12. What is the ratio of the Aid flow (current US$) in Greece in 1996 to that in 2001?
Give a very brief answer. 4.12. What is the ratio of the Aid flow (current US$) of Luxembourg in 1996 to that in 2001?
Your answer should be very brief. 3. What is the ratio of the Aid flow (current US$) of Australia in 1996 to that in 2001?
Provide a succinct answer. 0.33. What is the ratio of the Aid flow (current US$) in Finland in 1996 to that in 2001?
Keep it short and to the point. 0.01. What is the ratio of the Aid flow (current US$) of Greece in 1996 to that in 2002?
Offer a very short reply. 2.91. What is the ratio of the Aid flow (current US$) in Luxembourg in 1996 to that in 2002?
Your answer should be very brief. 1.4. What is the ratio of the Aid flow (current US$) of Finland in 1996 to that in 2002?
Provide a short and direct response. 0.01. What is the ratio of the Aid flow (current US$) of Greece in 1996 to that in 2003?
Offer a very short reply. 1.24. What is the ratio of the Aid flow (current US$) in Luxembourg in 1996 to that in 2003?
Keep it short and to the point. 1.75. What is the ratio of the Aid flow (current US$) in Finland in 1996 to that in 2003?
Your response must be concise. 0.02. What is the ratio of the Aid flow (current US$) of Greece in 1996 to that in 2004?
Provide a short and direct response. 2.25. What is the ratio of the Aid flow (current US$) of Luxembourg in 1996 to that in 2004?
Your answer should be compact. 0.81. What is the ratio of the Aid flow (current US$) in Australia in 1996 to that in 2004?
Your answer should be compact. 0.01. What is the ratio of the Aid flow (current US$) in Finland in 1996 to that in 2004?
Provide a short and direct response. 0.01. What is the ratio of the Aid flow (current US$) in Greece in 1997 to that in 1998?
Keep it short and to the point. 0.75. What is the ratio of the Aid flow (current US$) of Luxembourg in 1997 to that in 1998?
Offer a terse response. 0.83. What is the ratio of the Aid flow (current US$) of Australia in 1997 to that in 1998?
Your answer should be compact. 0.12. What is the ratio of the Aid flow (current US$) in Finland in 1997 to that in 1998?
Offer a terse response. 6. What is the ratio of the Aid flow (current US$) in Greece in 1997 to that in 1999?
Your response must be concise. 0.98. What is the ratio of the Aid flow (current US$) of Luxembourg in 1997 to that in 1999?
Your response must be concise. 2.11. What is the ratio of the Aid flow (current US$) in Australia in 1997 to that in 1999?
Your response must be concise. 0.07. What is the ratio of the Aid flow (current US$) in Finland in 1997 to that in 1999?
Give a very brief answer. 6. What is the ratio of the Aid flow (current US$) in Greece in 1997 to that in 2000?
Ensure brevity in your answer.  0.76. What is the ratio of the Aid flow (current US$) of Australia in 1997 to that in 2000?
Provide a short and direct response. 0.14. What is the ratio of the Aid flow (current US$) of Finland in 1997 to that in 2000?
Your response must be concise. 6. What is the ratio of the Aid flow (current US$) of Greece in 1997 to that in 2001?
Offer a very short reply. 3.54. What is the ratio of the Aid flow (current US$) in Luxembourg in 1997 to that in 2001?
Make the answer very short. 2.71. What is the ratio of the Aid flow (current US$) of Australia in 1997 to that in 2001?
Provide a succinct answer. 0.33. What is the ratio of the Aid flow (current US$) of Finland in 1997 to that in 2001?
Ensure brevity in your answer.  0. What is the ratio of the Aid flow (current US$) of Greece in 1997 to that in 2002?
Your response must be concise. 2.5. What is the ratio of the Aid flow (current US$) in Luxembourg in 1997 to that in 2002?
Keep it short and to the point. 1.27. What is the ratio of the Aid flow (current US$) in Australia in 1997 to that in 2002?
Make the answer very short. 0.33. What is the ratio of the Aid flow (current US$) of Finland in 1997 to that in 2002?
Ensure brevity in your answer.  0.01. What is the ratio of the Aid flow (current US$) in Luxembourg in 1997 to that in 2003?
Your response must be concise. 1.58. What is the ratio of the Aid flow (current US$) in Australia in 1997 to that in 2003?
Offer a terse response. 0.5. What is the ratio of the Aid flow (current US$) in Finland in 1997 to that in 2003?
Provide a short and direct response. 0.01. What is the ratio of the Aid flow (current US$) in Greece in 1997 to that in 2004?
Give a very brief answer. 1.93. What is the ratio of the Aid flow (current US$) in Luxembourg in 1997 to that in 2004?
Provide a succinct answer. 0.73. What is the ratio of the Aid flow (current US$) in Australia in 1997 to that in 2004?
Make the answer very short. 0.01. What is the ratio of the Aid flow (current US$) in Finland in 1997 to that in 2004?
Your answer should be very brief. 0.01. What is the ratio of the Aid flow (current US$) in Greece in 1998 to that in 1999?
Make the answer very short. 1.31. What is the ratio of the Aid flow (current US$) in Luxembourg in 1998 to that in 1999?
Offer a very short reply. 2.56. What is the ratio of the Aid flow (current US$) in Greece in 1998 to that in 2000?
Make the answer very short. 1.02. What is the ratio of the Aid flow (current US$) of Luxembourg in 1998 to that in 2000?
Your answer should be very brief. 2.3. What is the ratio of the Aid flow (current US$) of Finland in 1998 to that in 2000?
Ensure brevity in your answer.  1. What is the ratio of the Aid flow (current US$) of Greece in 1998 to that in 2001?
Your response must be concise. 4.75. What is the ratio of the Aid flow (current US$) in Luxembourg in 1998 to that in 2001?
Provide a short and direct response. 3.29. What is the ratio of the Aid flow (current US$) in Australia in 1998 to that in 2001?
Ensure brevity in your answer.  2.67. What is the ratio of the Aid flow (current US$) in Finland in 1998 to that in 2001?
Ensure brevity in your answer.  0. What is the ratio of the Aid flow (current US$) in Greece in 1998 to that in 2002?
Provide a succinct answer. 3.35. What is the ratio of the Aid flow (current US$) of Luxembourg in 1998 to that in 2002?
Ensure brevity in your answer.  1.53. What is the ratio of the Aid flow (current US$) of Australia in 1998 to that in 2002?
Provide a succinct answer. 2.67. What is the ratio of the Aid flow (current US$) in Finland in 1998 to that in 2002?
Your answer should be very brief. 0. What is the ratio of the Aid flow (current US$) of Greece in 1998 to that in 2003?
Your answer should be compact. 1.43. What is the ratio of the Aid flow (current US$) in Luxembourg in 1998 to that in 2003?
Make the answer very short. 1.92. What is the ratio of the Aid flow (current US$) in Finland in 1998 to that in 2003?
Offer a terse response. 0. What is the ratio of the Aid flow (current US$) of Greece in 1998 to that in 2004?
Offer a terse response. 2.59. What is the ratio of the Aid flow (current US$) in Luxembourg in 1998 to that in 2004?
Make the answer very short. 0.88. What is the ratio of the Aid flow (current US$) in Australia in 1998 to that in 2004?
Provide a short and direct response. 0.09. What is the ratio of the Aid flow (current US$) in Finland in 1998 to that in 2004?
Provide a succinct answer. 0. What is the ratio of the Aid flow (current US$) in Greece in 1999 to that in 2000?
Your response must be concise. 0.78. What is the ratio of the Aid flow (current US$) of Australia in 1999 to that in 2000?
Your answer should be compact. 2. What is the ratio of the Aid flow (current US$) of Finland in 1999 to that in 2000?
Keep it short and to the point. 1. What is the ratio of the Aid flow (current US$) of Greece in 1999 to that in 2001?
Your answer should be very brief. 3.62. What is the ratio of the Aid flow (current US$) in Luxembourg in 1999 to that in 2001?
Your answer should be compact. 1.29. What is the ratio of the Aid flow (current US$) of Australia in 1999 to that in 2001?
Ensure brevity in your answer.  4.67. What is the ratio of the Aid flow (current US$) in Finland in 1999 to that in 2001?
Your answer should be very brief. 0. What is the ratio of the Aid flow (current US$) of Greece in 1999 to that in 2002?
Make the answer very short. 2.56. What is the ratio of the Aid flow (current US$) of Luxembourg in 1999 to that in 2002?
Your answer should be very brief. 0.6. What is the ratio of the Aid flow (current US$) in Australia in 1999 to that in 2002?
Offer a terse response. 4.67. What is the ratio of the Aid flow (current US$) of Finland in 1999 to that in 2002?
Provide a short and direct response. 0. What is the ratio of the Aid flow (current US$) of Greece in 1999 to that in 2003?
Provide a succinct answer. 1.09. What is the ratio of the Aid flow (current US$) of Australia in 1999 to that in 2003?
Provide a succinct answer. 7. What is the ratio of the Aid flow (current US$) in Finland in 1999 to that in 2003?
Keep it short and to the point. 0. What is the ratio of the Aid flow (current US$) of Greece in 1999 to that in 2004?
Offer a terse response. 1.98. What is the ratio of the Aid flow (current US$) of Luxembourg in 1999 to that in 2004?
Provide a short and direct response. 0.35. What is the ratio of the Aid flow (current US$) of Australia in 1999 to that in 2004?
Your answer should be very brief. 0.16. What is the ratio of the Aid flow (current US$) in Finland in 1999 to that in 2004?
Keep it short and to the point. 0. What is the ratio of the Aid flow (current US$) of Greece in 2000 to that in 2001?
Ensure brevity in your answer.  4.67. What is the ratio of the Aid flow (current US$) in Luxembourg in 2000 to that in 2001?
Make the answer very short. 1.43. What is the ratio of the Aid flow (current US$) of Australia in 2000 to that in 2001?
Your answer should be very brief. 2.33. What is the ratio of the Aid flow (current US$) of Finland in 2000 to that in 2001?
Keep it short and to the point. 0. What is the ratio of the Aid flow (current US$) of Greece in 2000 to that in 2002?
Your response must be concise. 3.29. What is the ratio of the Aid flow (current US$) in Luxembourg in 2000 to that in 2002?
Give a very brief answer. 0.67. What is the ratio of the Aid flow (current US$) of Australia in 2000 to that in 2002?
Your answer should be very brief. 2.33. What is the ratio of the Aid flow (current US$) in Finland in 2000 to that in 2002?
Your answer should be very brief. 0. What is the ratio of the Aid flow (current US$) in Australia in 2000 to that in 2003?
Keep it short and to the point. 3.5. What is the ratio of the Aid flow (current US$) of Finland in 2000 to that in 2003?
Offer a terse response. 0. What is the ratio of the Aid flow (current US$) in Greece in 2000 to that in 2004?
Keep it short and to the point. 2.55. What is the ratio of the Aid flow (current US$) of Luxembourg in 2000 to that in 2004?
Provide a succinct answer. 0.38. What is the ratio of the Aid flow (current US$) of Australia in 2000 to that in 2004?
Give a very brief answer. 0.08. What is the ratio of the Aid flow (current US$) in Finland in 2000 to that in 2004?
Offer a very short reply. 0. What is the ratio of the Aid flow (current US$) in Greece in 2001 to that in 2002?
Offer a terse response. 0.71. What is the ratio of the Aid flow (current US$) in Luxembourg in 2001 to that in 2002?
Provide a succinct answer. 0.47. What is the ratio of the Aid flow (current US$) of Australia in 2001 to that in 2002?
Provide a short and direct response. 1. What is the ratio of the Aid flow (current US$) of Finland in 2001 to that in 2002?
Offer a very short reply. 1.3. What is the ratio of the Aid flow (current US$) of Luxembourg in 2001 to that in 2003?
Provide a succinct answer. 0.58. What is the ratio of the Aid flow (current US$) of Finland in 2001 to that in 2003?
Your response must be concise. 1.66. What is the ratio of the Aid flow (current US$) in Greece in 2001 to that in 2004?
Provide a short and direct response. 0.55. What is the ratio of the Aid flow (current US$) of Luxembourg in 2001 to that in 2004?
Your answer should be very brief. 0.27. What is the ratio of the Aid flow (current US$) in Australia in 2001 to that in 2004?
Offer a very short reply. 0.03. What is the ratio of the Aid flow (current US$) of Finland in 2001 to that in 2004?
Provide a succinct answer. 1.12. What is the ratio of the Aid flow (current US$) in Greece in 2002 to that in 2003?
Your answer should be very brief. 0.42. What is the ratio of the Aid flow (current US$) of Luxembourg in 2002 to that in 2003?
Make the answer very short. 1.25. What is the ratio of the Aid flow (current US$) of Finland in 2002 to that in 2003?
Ensure brevity in your answer.  1.28. What is the ratio of the Aid flow (current US$) in Greece in 2002 to that in 2004?
Your answer should be very brief. 0.77. What is the ratio of the Aid flow (current US$) of Luxembourg in 2002 to that in 2004?
Ensure brevity in your answer.  0.58. What is the ratio of the Aid flow (current US$) in Australia in 2002 to that in 2004?
Your answer should be compact. 0.03. What is the ratio of the Aid flow (current US$) in Finland in 2002 to that in 2004?
Your answer should be compact. 0.86. What is the ratio of the Aid flow (current US$) of Greece in 2003 to that in 2004?
Offer a terse response. 1.82. What is the ratio of the Aid flow (current US$) of Luxembourg in 2003 to that in 2004?
Provide a succinct answer. 0.46. What is the ratio of the Aid flow (current US$) of Australia in 2003 to that in 2004?
Provide a succinct answer. 0.02. What is the ratio of the Aid flow (current US$) in Finland in 2003 to that in 2004?
Provide a short and direct response. 0.67. What is the difference between the highest and the second highest Aid flow (current US$) in Luxembourg?
Keep it short and to the point. 3.00e+04. What is the difference between the highest and the second highest Aid flow (current US$) of Australia?
Ensure brevity in your answer.  7.20e+05. What is the difference between the highest and the second highest Aid flow (current US$) of Finland?
Your answer should be very brief. 1.34e+06. What is the difference between the highest and the lowest Aid flow (current US$) of Greece?
Offer a terse response. 9.00e+05. What is the difference between the highest and the lowest Aid flow (current US$) of Australia?
Make the answer very short. 8.50e+05. What is the difference between the highest and the lowest Aid flow (current US$) of Finland?
Make the answer very short. 1.28e+07. 